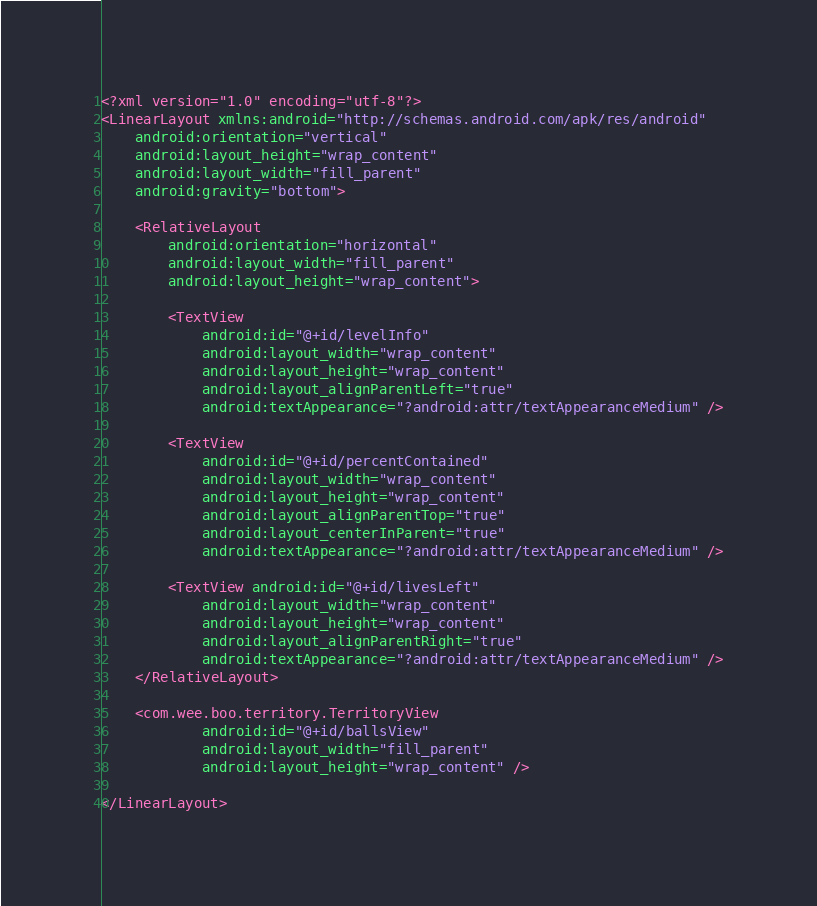Convert code to text. <code><loc_0><loc_0><loc_500><loc_500><_XML_><?xml version="1.0" encoding="utf-8"?>
<LinearLayout xmlns:android="http://schemas.android.com/apk/res/android"
    android:orientation="vertical"
    android:layout_height="wrap_content"
    android:layout_width="fill_parent"
    android:gravity="bottom">

    <RelativeLayout
        android:orientation="horizontal"
        android:layout_width="fill_parent"
        android:layout_height="wrap_content">

        <TextView
            android:id="@+id/levelInfo"
            android:layout_width="wrap_content"
            android:layout_height="wrap_content"
            android:layout_alignParentLeft="true"
            android:textAppearance="?android:attr/textAppearanceMedium" />

        <TextView
            android:id="@+id/percentContained"
            android:layout_width="wrap_content"
            android:layout_height="wrap_content"
            android:layout_alignParentTop="true"
            android:layout_centerInParent="true"
            android:textAppearance="?android:attr/textAppearanceMedium" />

        <TextView android:id="@+id/livesLeft"
            android:layout_width="wrap_content"
            android:layout_height="wrap_content"
            android:layout_alignParentRight="true"
            android:textAppearance="?android:attr/textAppearanceMedium" />
    </RelativeLayout>

    <com.wee.boo.territory.TerritoryView
            android:id="@+id/ballsView"
            android:layout_width="fill_parent"
            android:layout_height="wrap_content" />

</LinearLayout>
</code> 